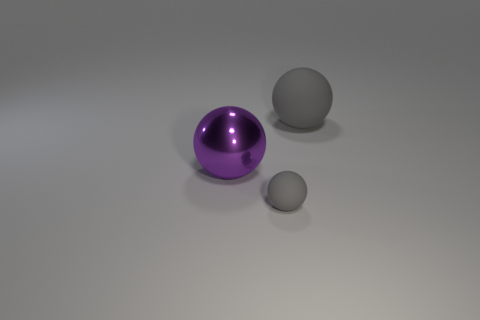The other tiny thing that is the same shape as the purple shiny object is what color?
Your answer should be very brief. Gray. How many small rubber things have the same color as the small rubber ball?
Your answer should be compact. 0. Are there any other things that have the same shape as the big metal object?
Make the answer very short. Yes. There is a gray thing behind the large ball on the left side of the large matte thing; are there any large purple things that are left of it?
Ensure brevity in your answer.  Yes. How many purple balls are the same material as the large gray object?
Offer a very short reply. 0. There is a gray ball that is right of the tiny gray sphere; does it have the same size as the gray matte ball in front of the large metal ball?
Ensure brevity in your answer.  No. There is a big thing on the left side of the gray matte ball in front of the gray matte ball that is to the right of the small rubber thing; what color is it?
Make the answer very short. Purple. Are there any blue rubber things that have the same shape as the large gray object?
Provide a succinct answer. No. Are there an equal number of large gray rubber balls that are to the left of the small gray matte sphere and purple metallic spheres that are in front of the purple thing?
Provide a succinct answer. Yes. There is a gray matte thing that is behind the tiny gray ball; is it the same shape as the purple object?
Your answer should be compact. Yes. 